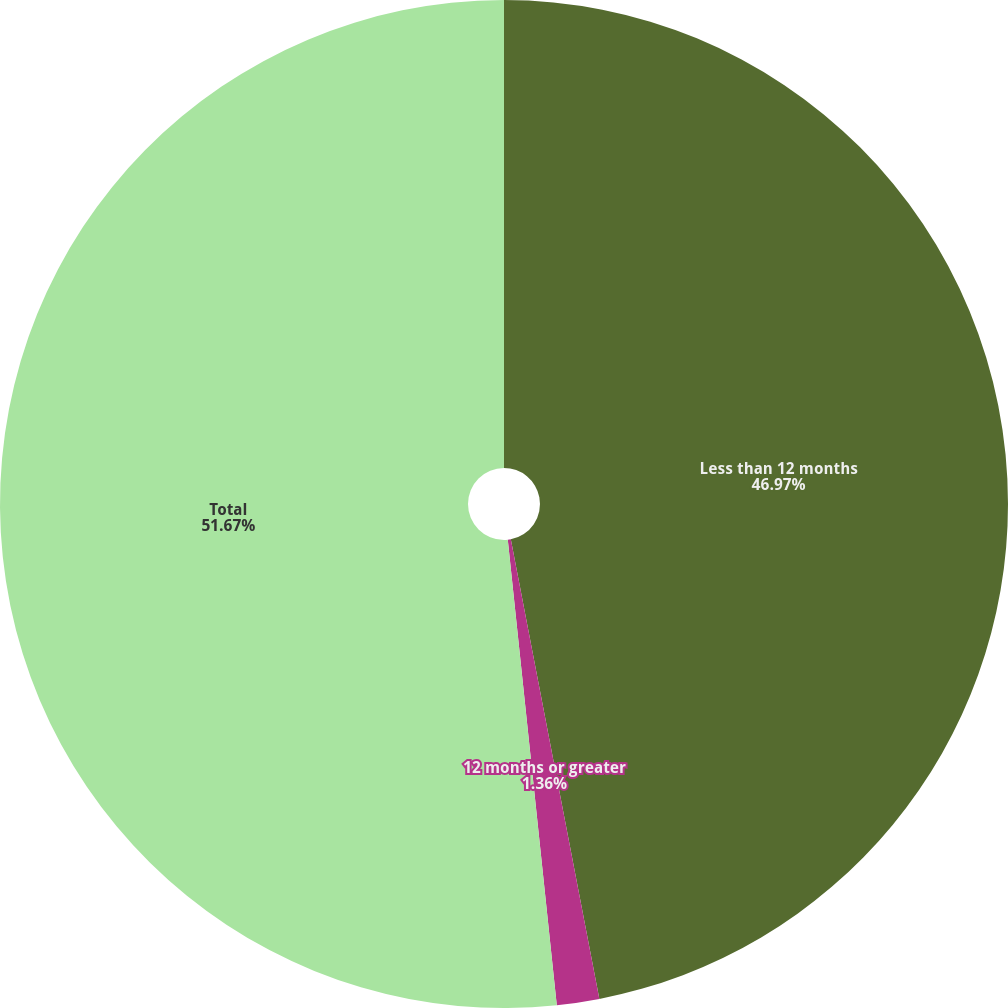Convert chart to OTSL. <chart><loc_0><loc_0><loc_500><loc_500><pie_chart><fcel>Less than 12 months<fcel>12 months or greater<fcel>Total<nl><fcel>46.97%<fcel>1.36%<fcel>51.67%<nl></chart> 